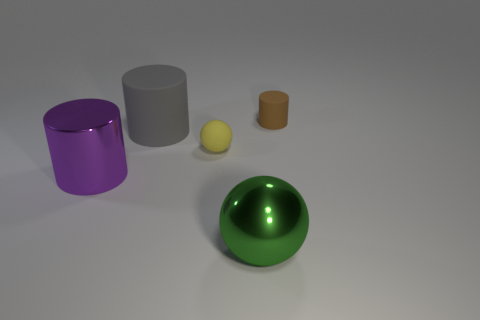Add 1 big blue metal cylinders. How many objects exist? 6 Subtract all cylinders. How many objects are left? 2 Add 2 small brown things. How many small brown things exist? 3 Subtract 0 purple spheres. How many objects are left? 5 Subtract all big things. Subtract all brown rubber cylinders. How many objects are left? 1 Add 2 brown things. How many brown things are left? 3 